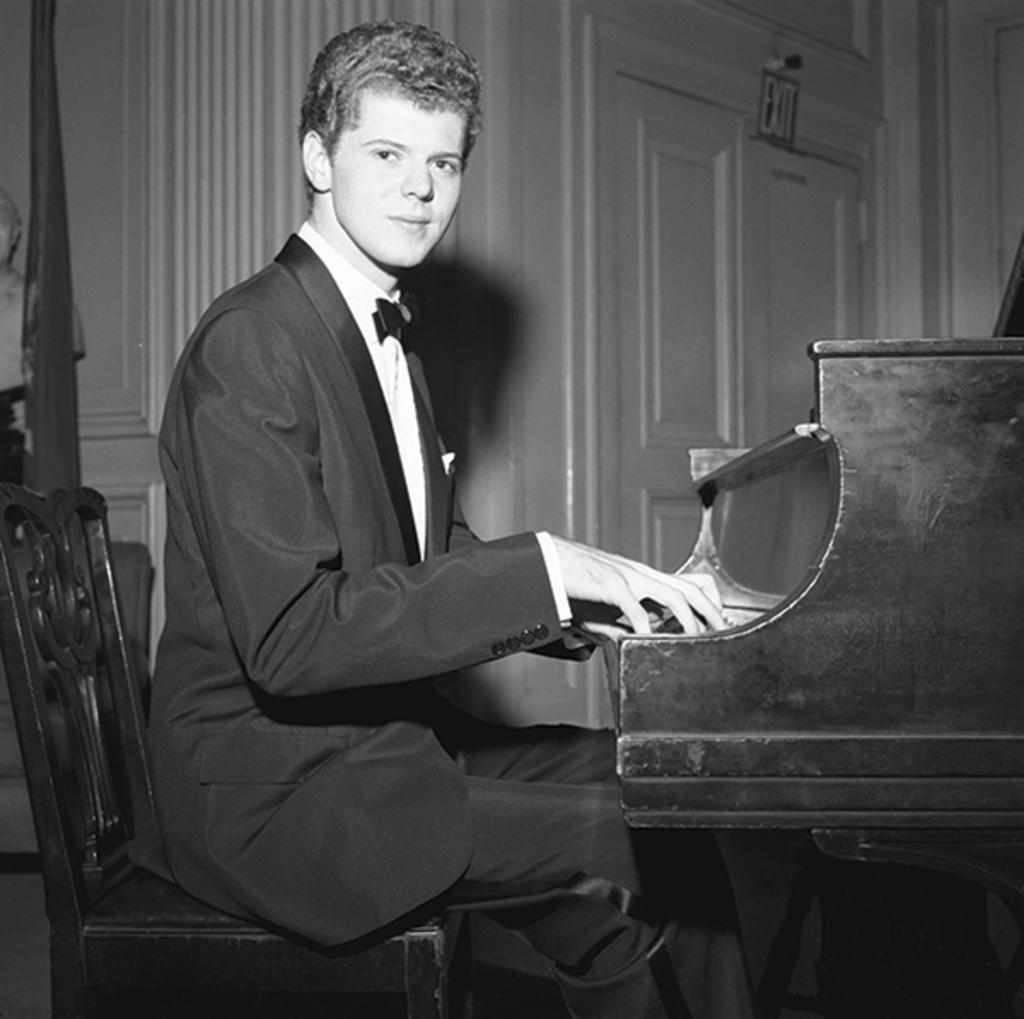Who is the main subject in the image? There is a man in the image. What is the man doing in the image? The man is sitting in a chair and playing a piano. What can be seen in the background of the image? There is a door visible in the background of the image. How many frogs are jumping on the waves in the image? There are no waves or frogs present in the image. 